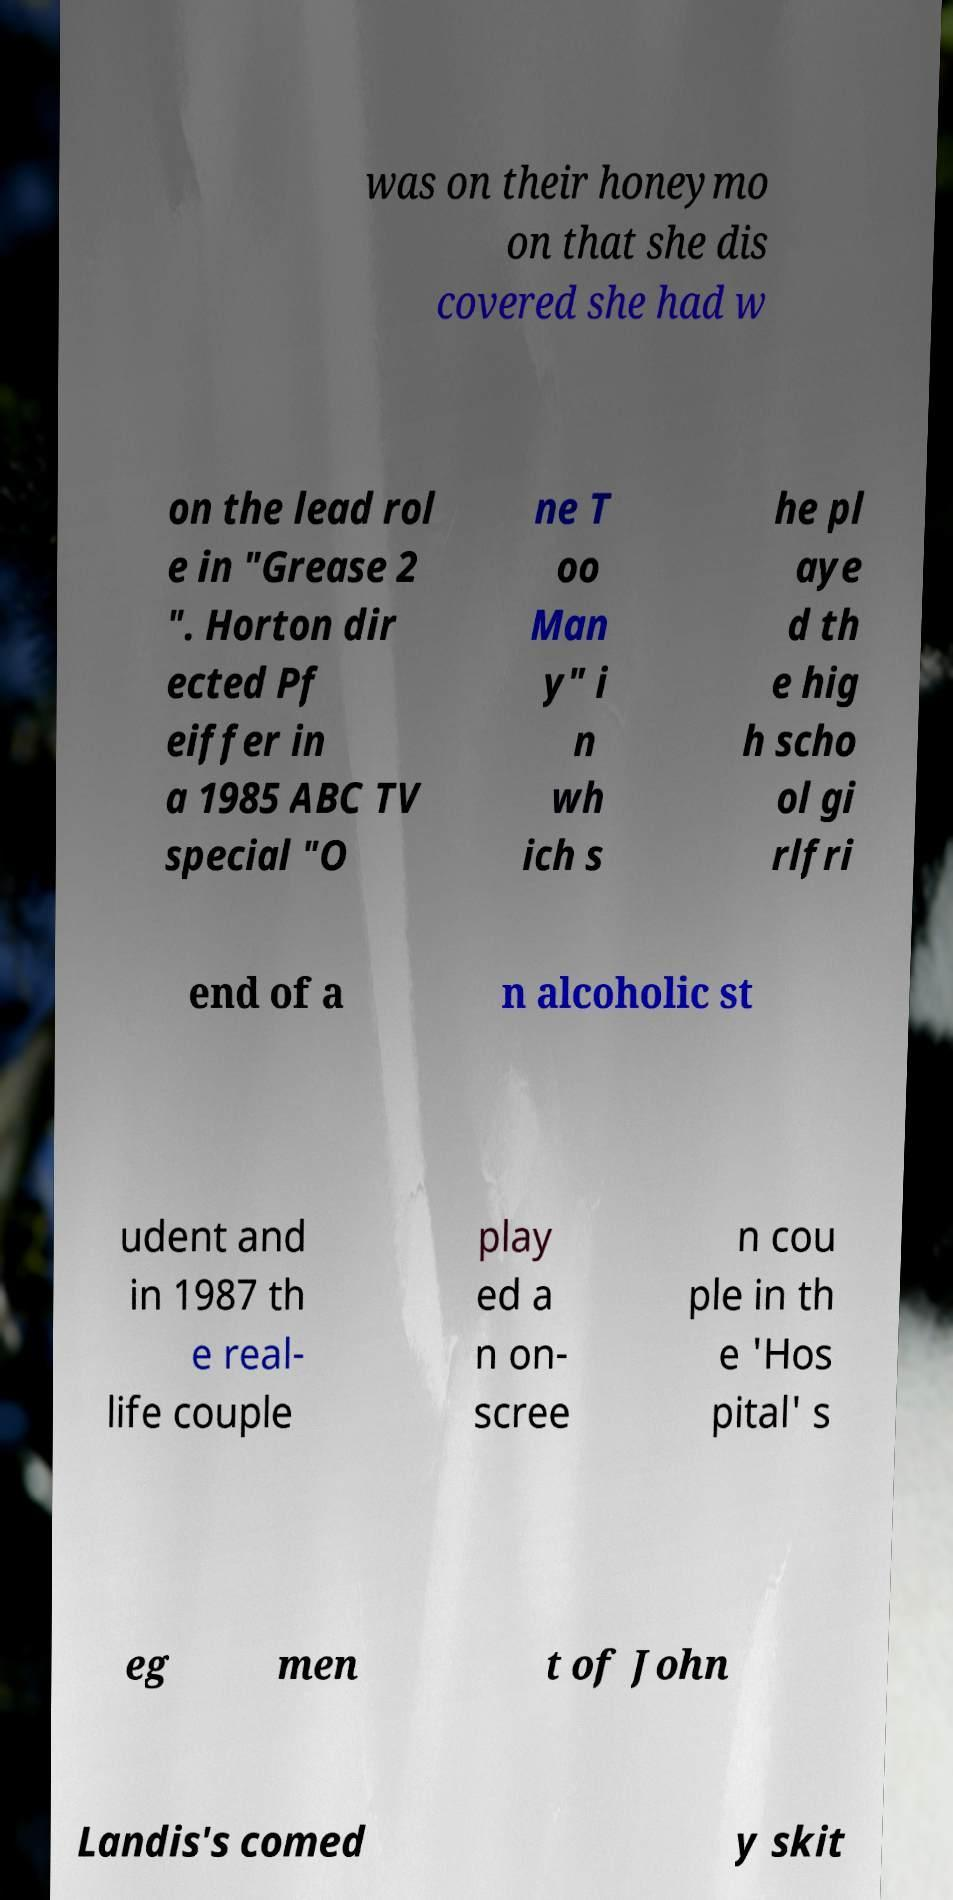Could you assist in decoding the text presented in this image and type it out clearly? was on their honeymo on that she dis covered she had w on the lead rol e in "Grease 2 ". Horton dir ected Pf eiffer in a 1985 ABC TV special "O ne T oo Man y" i n wh ich s he pl aye d th e hig h scho ol gi rlfri end of a n alcoholic st udent and in 1987 th e real- life couple play ed a n on- scree n cou ple in th e 'Hos pital' s eg men t of John Landis's comed y skit 